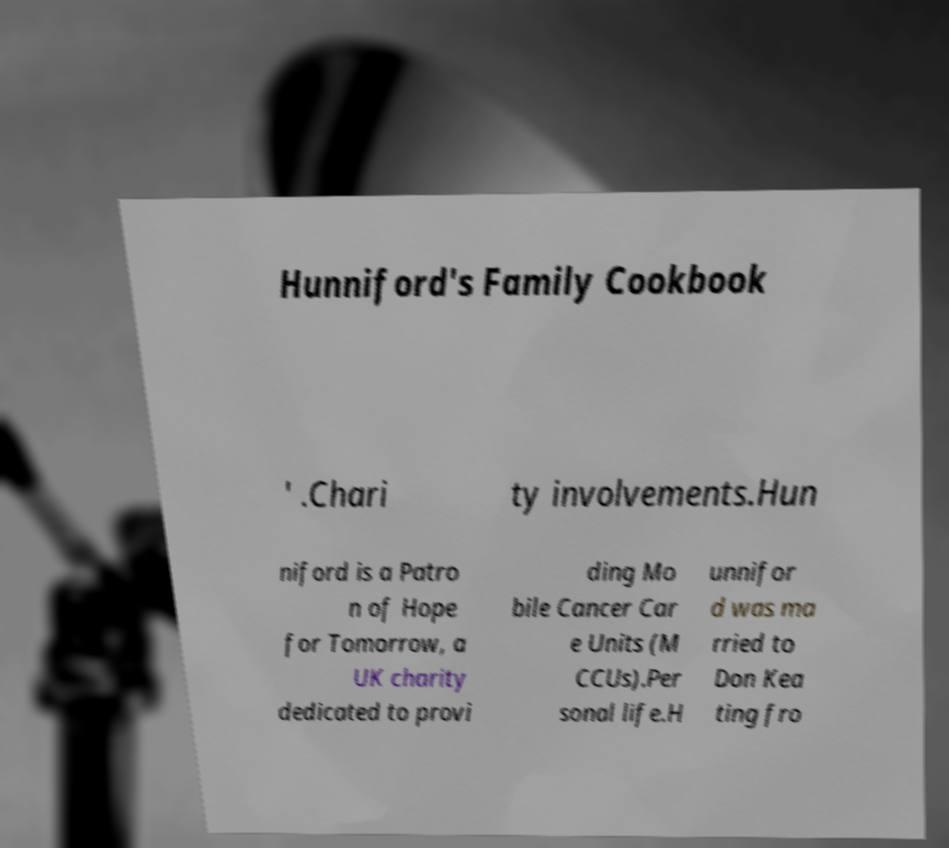Can you read and provide the text displayed in the image?This photo seems to have some interesting text. Can you extract and type it out for me? Hunniford's Family Cookbook ' .Chari ty involvements.Hun niford is a Patro n of Hope for Tomorrow, a UK charity dedicated to provi ding Mo bile Cancer Car e Units (M CCUs).Per sonal life.H unnifor d was ma rried to Don Kea ting fro 